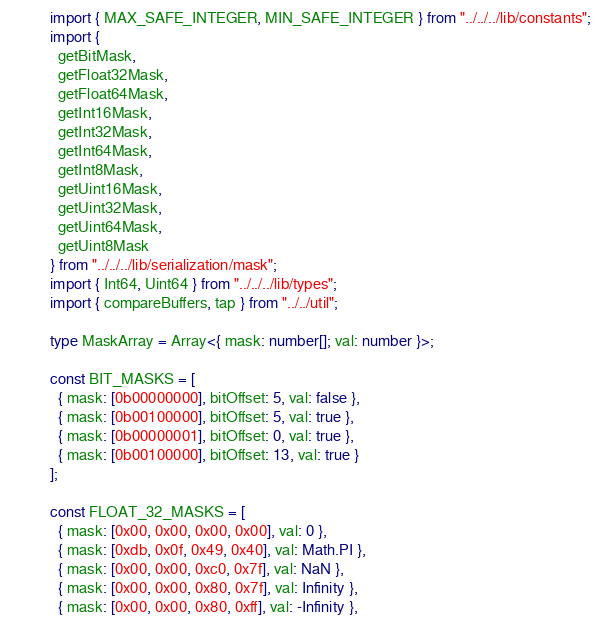<code> <loc_0><loc_0><loc_500><loc_500><_TypeScript_>import { MAX_SAFE_INTEGER, MIN_SAFE_INTEGER } from "../../../lib/constants";
import {
  getBitMask,
  getFloat32Mask,
  getFloat64Mask,
  getInt16Mask,
  getInt32Mask,
  getInt64Mask,
  getInt8Mask,
  getUint16Mask,
  getUint32Mask,
  getUint64Mask,
  getUint8Mask
} from "../../../lib/serialization/mask";
import { Int64, Uint64 } from "../../../lib/types";
import { compareBuffers, tap } from "../../util";

type MaskArray = Array<{ mask: number[]; val: number }>;

const BIT_MASKS = [
  { mask: [0b00000000], bitOffset: 5, val: false },
  { mask: [0b00100000], bitOffset: 5, val: true },
  { mask: [0b00000001], bitOffset: 0, val: true },
  { mask: [0b00100000], bitOffset: 13, val: true }
];

const FLOAT_32_MASKS = [
  { mask: [0x00, 0x00, 0x00, 0x00], val: 0 },
  { mask: [0xdb, 0x0f, 0x49, 0x40], val: Math.PI },
  { mask: [0x00, 0x00, 0xc0, 0x7f], val: NaN },
  { mask: [0x00, 0x00, 0x80, 0x7f], val: Infinity },
  { mask: [0x00, 0x00, 0x80, 0xff], val: -Infinity },</code> 